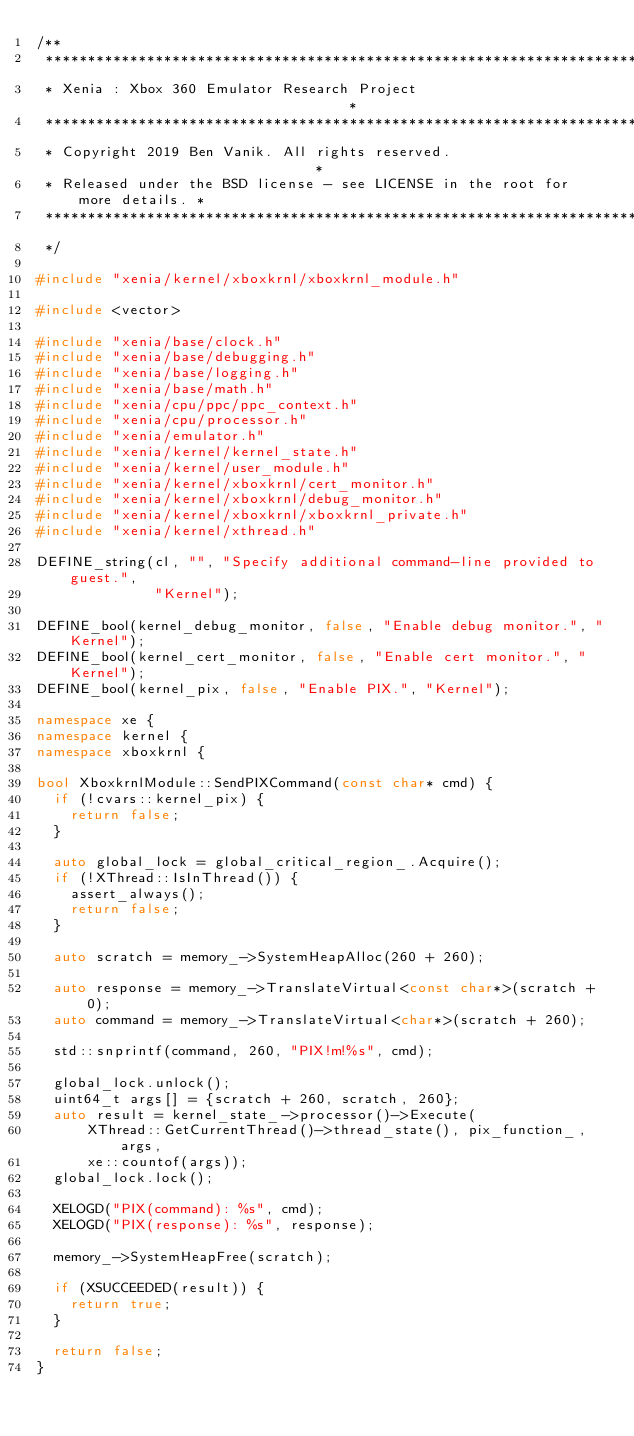<code> <loc_0><loc_0><loc_500><loc_500><_C++_>/**
 ******************************************************************************
 * Xenia : Xbox 360 Emulator Research Project                                 *
 ******************************************************************************
 * Copyright 2019 Ben Vanik. All rights reserved.                             *
 * Released under the BSD license - see LICENSE in the root for more details. *
 ******************************************************************************
 */

#include "xenia/kernel/xboxkrnl/xboxkrnl_module.h"

#include <vector>

#include "xenia/base/clock.h"
#include "xenia/base/debugging.h"
#include "xenia/base/logging.h"
#include "xenia/base/math.h"
#include "xenia/cpu/ppc/ppc_context.h"
#include "xenia/cpu/processor.h"
#include "xenia/emulator.h"
#include "xenia/kernel/kernel_state.h"
#include "xenia/kernel/user_module.h"
#include "xenia/kernel/xboxkrnl/cert_monitor.h"
#include "xenia/kernel/xboxkrnl/debug_monitor.h"
#include "xenia/kernel/xboxkrnl/xboxkrnl_private.h"
#include "xenia/kernel/xthread.h"

DEFINE_string(cl, "", "Specify additional command-line provided to guest.",
              "Kernel");

DEFINE_bool(kernel_debug_monitor, false, "Enable debug monitor.", "Kernel");
DEFINE_bool(kernel_cert_monitor, false, "Enable cert monitor.", "Kernel");
DEFINE_bool(kernel_pix, false, "Enable PIX.", "Kernel");

namespace xe {
namespace kernel {
namespace xboxkrnl {

bool XboxkrnlModule::SendPIXCommand(const char* cmd) {
  if (!cvars::kernel_pix) {
    return false;
  }

  auto global_lock = global_critical_region_.Acquire();
  if (!XThread::IsInThread()) {
    assert_always();
    return false;
  }

  auto scratch = memory_->SystemHeapAlloc(260 + 260);

  auto response = memory_->TranslateVirtual<const char*>(scratch + 0);
  auto command = memory_->TranslateVirtual<char*>(scratch + 260);

  std::snprintf(command, 260, "PIX!m!%s", cmd);

  global_lock.unlock();
  uint64_t args[] = {scratch + 260, scratch, 260};
  auto result = kernel_state_->processor()->Execute(
      XThread::GetCurrentThread()->thread_state(), pix_function_, args,
      xe::countof(args));
  global_lock.lock();

  XELOGD("PIX(command): %s", cmd);
  XELOGD("PIX(response): %s", response);

  memory_->SystemHeapFree(scratch);

  if (XSUCCEEDED(result)) {
    return true;
  }

  return false;
}
</code> 